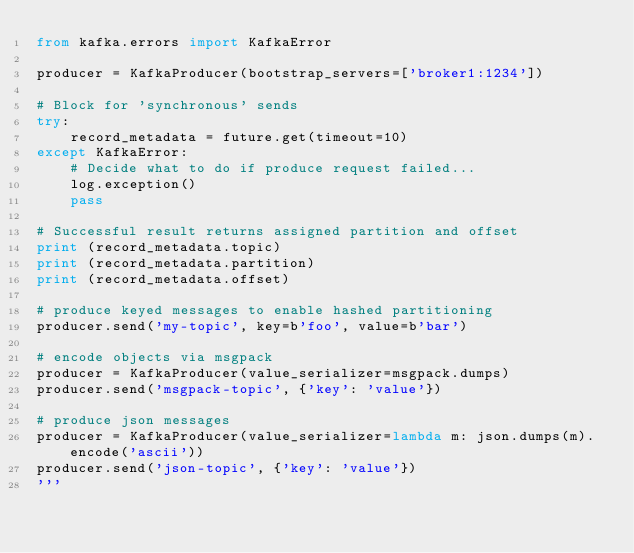<code> <loc_0><loc_0><loc_500><loc_500><_Python_>from kafka.errors import KafkaError

producer = KafkaProducer(bootstrap_servers=['broker1:1234'])

# Block for 'synchronous' sends
try:
    record_metadata = future.get(timeout=10)
except KafkaError:
    # Decide what to do if produce request failed...
    log.exception()
    pass

# Successful result returns assigned partition and offset
print (record_metadata.topic)
print (record_metadata.partition)
print (record_metadata.offset)

# produce keyed messages to enable hashed partitioning
producer.send('my-topic', key=b'foo', value=b'bar')

# encode objects via msgpack
producer = KafkaProducer(value_serializer=msgpack.dumps)
producer.send('msgpack-topic', {'key': 'value'})

# produce json messages
producer = KafkaProducer(value_serializer=lambda m: json.dumps(m).encode('ascii'))
producer.send('json-topic', {'key': 'value'})
'''
</code> 